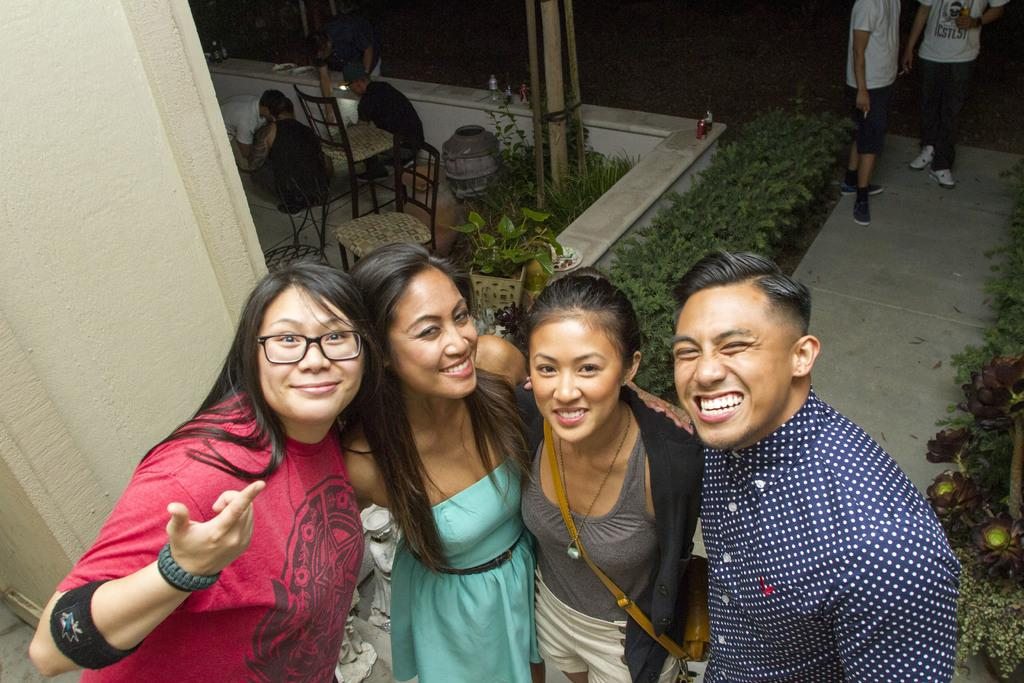What are the people in the middle of the image doing? The people in the middle of the image are standing and smiling. What can be seen behind the people? There are plants and chairs behind the people. What else is visible in the background of the image? There are poles and people standing and sitting in the background. What type of fuel can be seen being used by the cattle in the image? There are no cattle present in the image, so it is not possible to determine what type of fuel they might be using. 